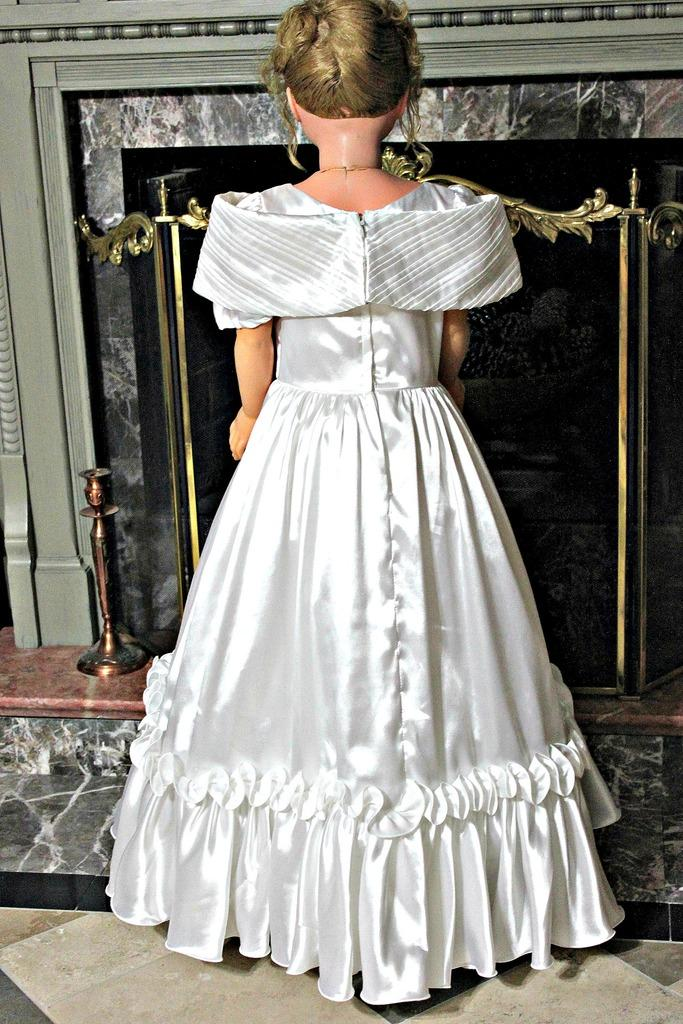What is the main subject in the image? There is a doll in the image. What is the doll wearing? The doll is wearing a white dress. What type of feature can be seen in the background of the image? There is a fireplace visible in the image. What is the color of the fireplace? The fireplace is in black and ash color. How many bags can be seen on the doll in the image? There are no bags present on the doll in the image. What type of ray is visible in the image? There is no ray visible in the image. 